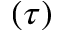<formula> <loc_0><loc_0><loc_500><loc_500>( \tau )</formula> 